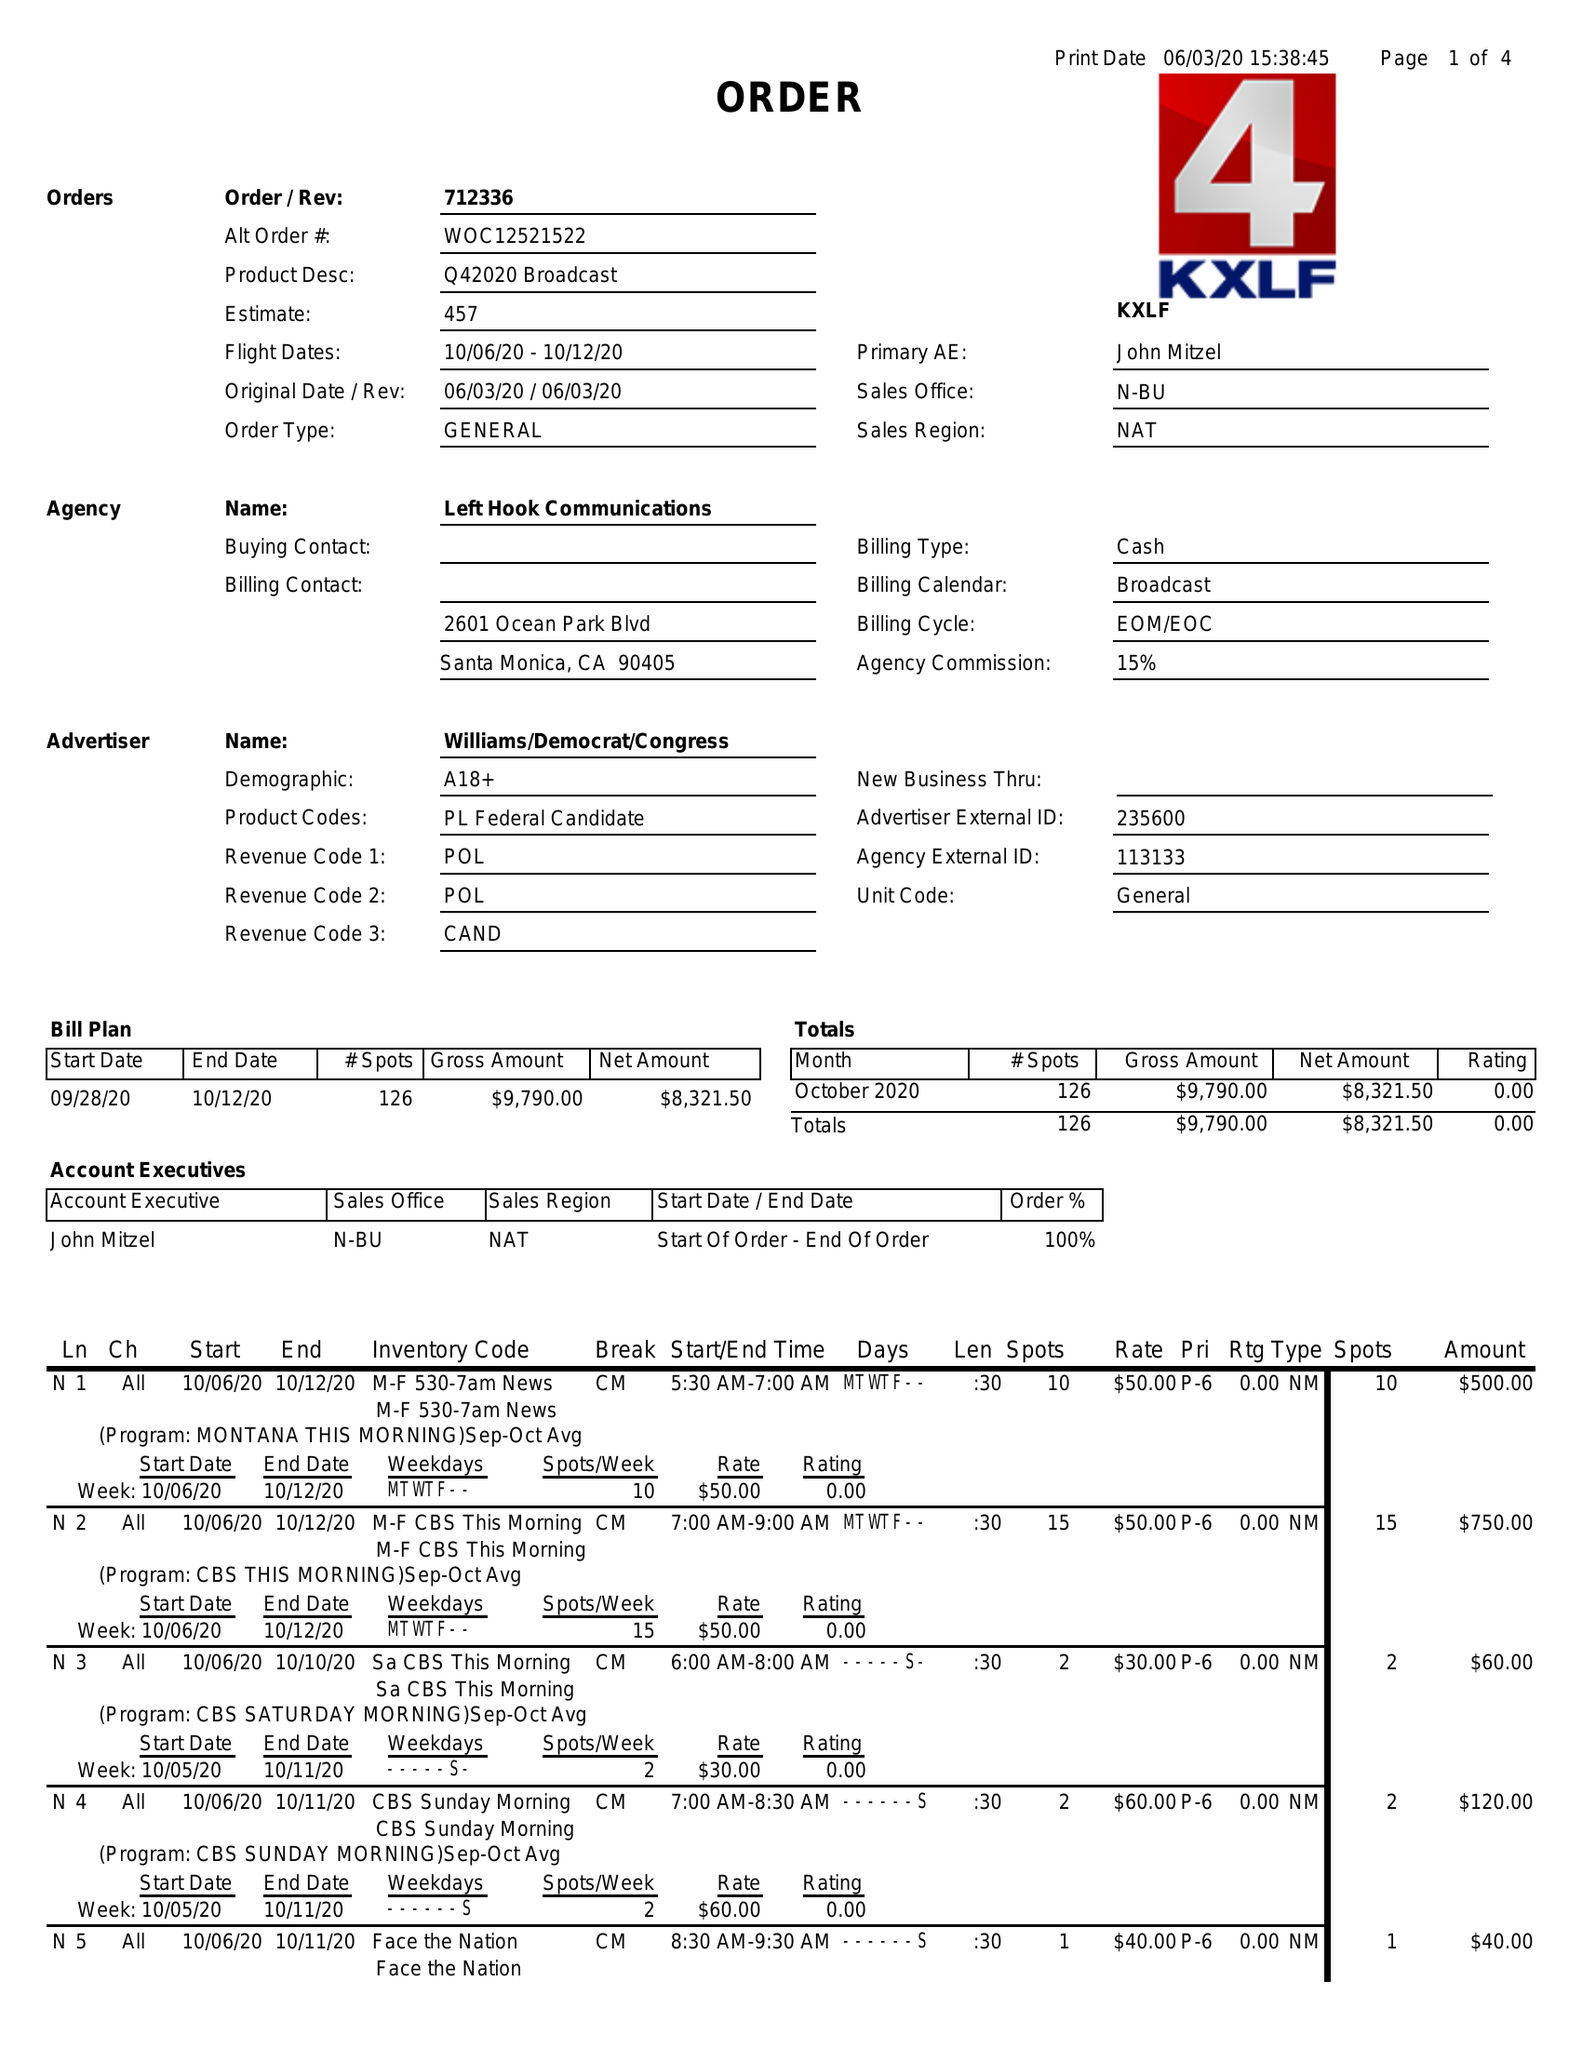What is the value for the flight_from?
Answer the question using a single word or phrase. 10/06/20 